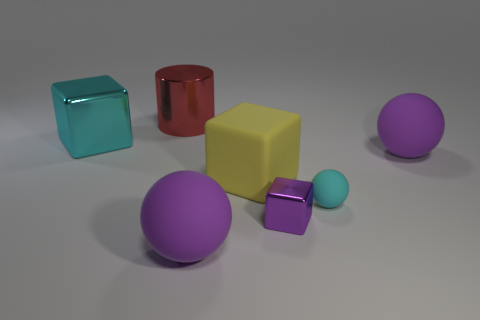Does the arrangement of the objects suggest any particular theme or purpose? The arrangement seems random and doesn't directly suggest a particular theme or purpose. It could be interpreted as an abstract composition or a setup for a 3D modeling or render test. The diversity of colors and forms can elicit a sense of playfulness or be used to study contrasts and harmony between different shapes. 